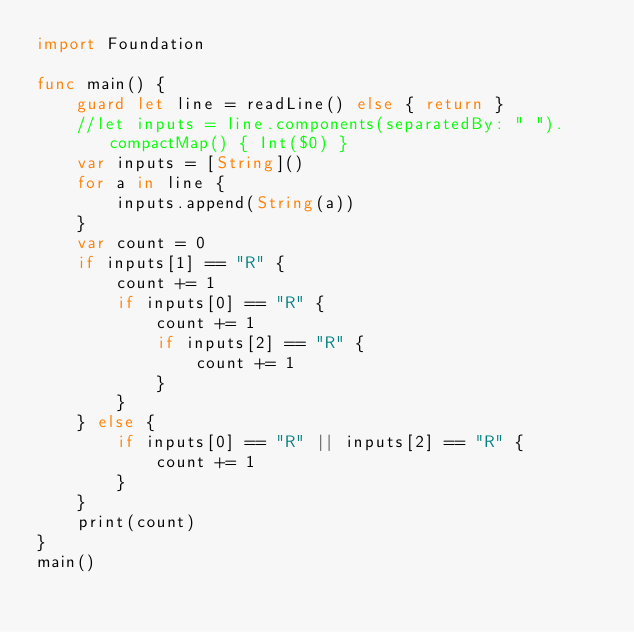Convert code to text. <code><loc_0><loc_0><loc_500><loc_500><_Swift_>import Foundation

func main() {
    guard let line = readLine() else { return }
    //let inputs = line.components(separatedBy: " ").compactMap() { Int($0) }
    var inputs = [String]()
    for a in line {
        inputs.append(String(a))
    }
    var count = 0
    if inputs[1] == "R" {
        count += 1
        if inputs[0] == "R" {
            count += 1
            if inputs[2] == "R" {
                count += 1
            }
        }
    } else {
        if inputs[0] == "R" || inputs[2] == "R" {
            count += 1
        }
    }
    print(count)
}
main()
</code> 